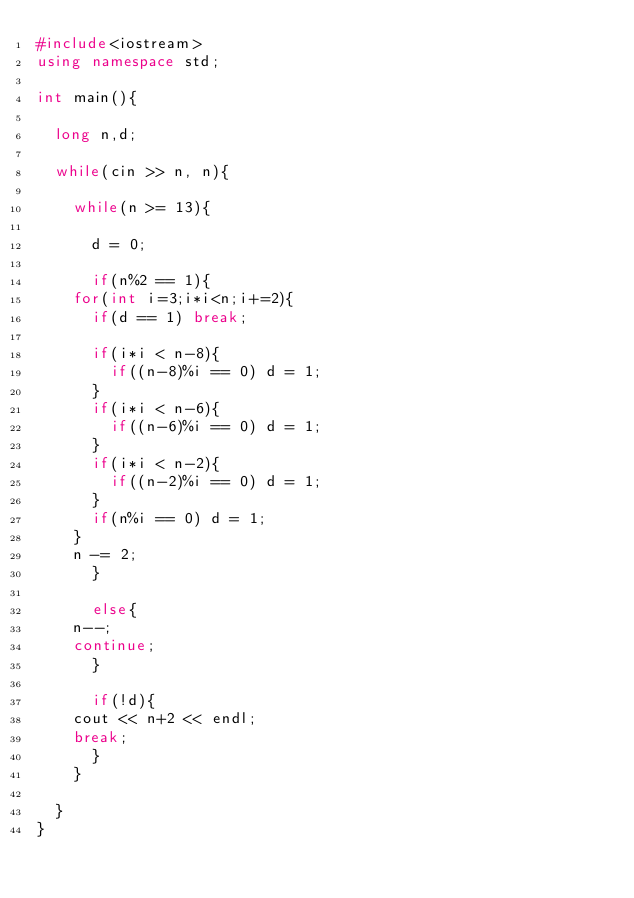<code> <loc_0><loc_0><loc_500><loc_500><_C++_>#include<iostream>
using namespace std;

int main(){

  long n,d;

  while(cin >> n, n){

    while(n >= 13){

      d = 0;

      if(n%2 == 1){
	for(int i=3;i*i<n;i+=2){
	  if(d == 1) break;

	  if(i*i < n-8){
	    if((n-8)%i == 0) d = 1;
	  }
	  if(i*i < n-6){
	    if((n-6)%i == 0) d = 1;
	  }
	  if(i*i < n-2){
	    if((n-2)%i == 0) d = 1;
	  }
	  if(n%i == 0) d = 1;
	}
	n -= 2;
      }

      else{
	n--;
	continue;
      }

      if(!d){
	cout << n+2 << endl;
	break;
      }
    }

  }
}</code> 